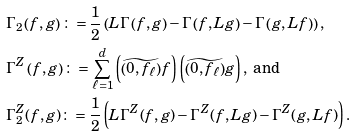<formula> <loc_0><loc_0><loc_500><loc_500>& \Gamma _ { 2 } \left ( f , g \right ) \colon = \frac { 1 } { 2 } \left ( L \Gamma \left ( f , g \right ) - \Gamma \left ( f , L g \right ) - \Gamma \left ( g , L f \right ) \right ) , \\ & \Gamma ^ { Z } \left ( f , g \right ) \colon = \sum _ { \ell = 1 } ^ { d } \left ( \widetilde { \left ( 0 , f _ { \ell } \right ) } f \right ) \left ( \widetilde { \left ( 0 , f _ { \ell } \right ) } g \right ) , \text { and} \\ & \Gamma _ { 2 } ^ { Z } ( f , g ) \colon = \frac { 1 } { 2 } \left ( L \Gamma ^ { Z } ( f , g ) - \Gamma ^ { Z } ( f , L g ) - \Gamma ^ { Z } ( g , L f ) \right ) .</formula> 